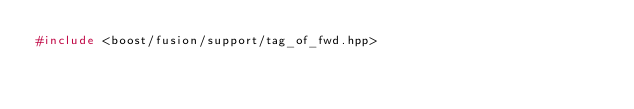<code> <loc_0><loc_0><loc_500><loc_500><_C++_>#include <boost/fusion/support/tag_of_fwd.hpp>
</code> 